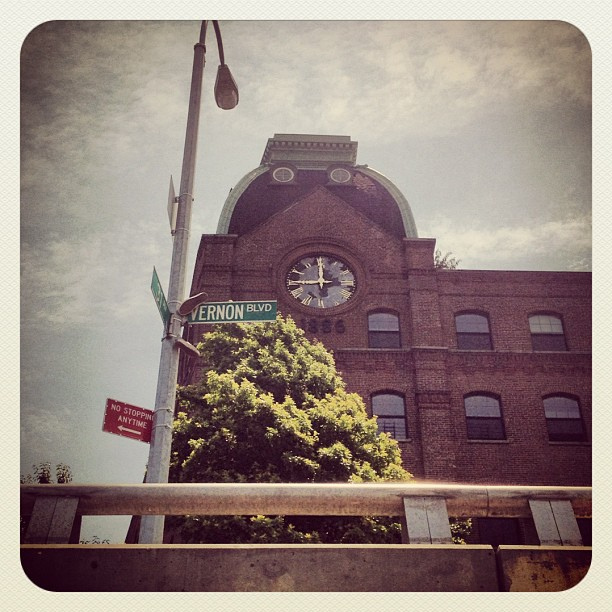There's a sign that says 'NO STOPPING ANYTIME'; what does that indicate about the area? The presence of 'NO STOPPING ANYTIME' signs suggests that this area likely experiences high traffic flow or is a key route where maintaining clear lanes is crucial for traffic management and safety reasons. 